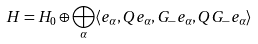Convert formula to latex. <formula><loc_0><loc_0><loc_500><loc_500>H = H _ { 0 } \oplus \bigoplus _ { \alpha } \langle e _ { \alpha } , Q e _ { \alpha } , G _ { - } e _ { \alpha } , Q G _ { - } e _ { \alpha } \rangle</formula> 